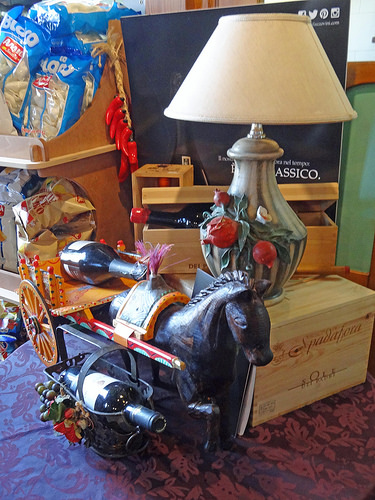<image>
Is there a lamp on the table? No. The lamp is not positioned on the table. They may be near each other, but the lamp is not supported by or resting on top of the table. 